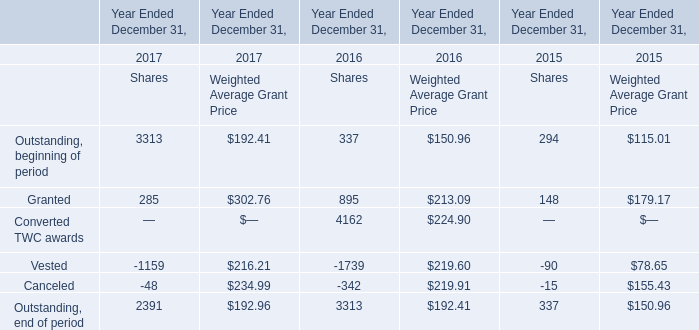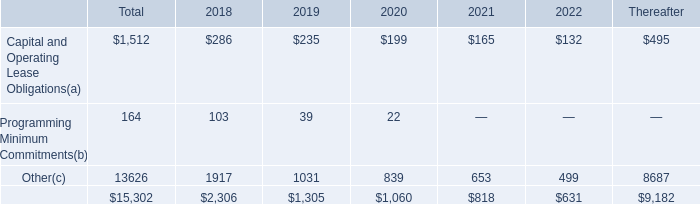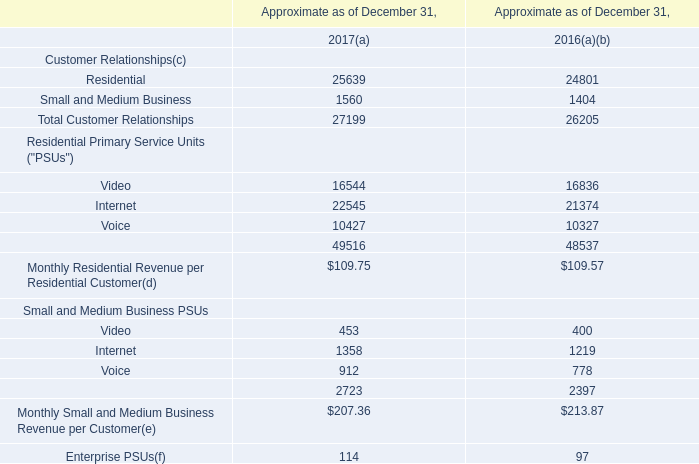What's the average of the Granted for Shares in the years where Total Customer Relationships for Customer Relationships(c) is positive? 
Computations: ((285 + 895) / 2)
Answer: 590.0. 